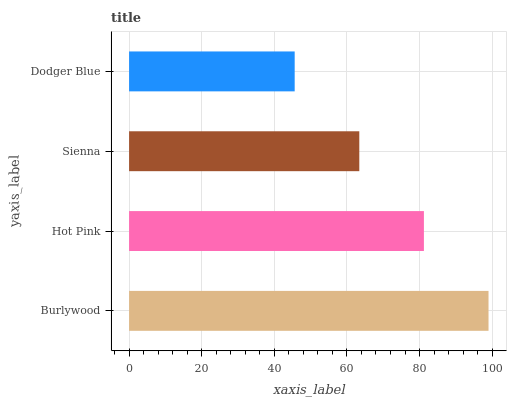Is Dodger Blue the minimum?
Answer yes or no. Yes. Is Burlywood the maximum?
Answer yes or no. Yes. Is Hot Pink the minimum?
Answer yes or no. No. Is Hot Pink the maximum?
Answer yes or no. No. Is Burlywood greater than Hot Pink?
Answer yes or no. Yes. Is Hot Pink less than Burlywood?
Answer yes or no. Yes. Is Hot Pink greater than Burlywood?
Answer yes or no. No. Is Burlywood less than Hot Pink?
Answer yes or no. No. Is Hot Pink the high median?
Answer yes or no. Yes. Is Sienna the low median?
Answer yes or no. Yes. Is Burlywood the high median?
Answer yes or no. No. Is Burlywood the low median?
Answer yes or no. No. 